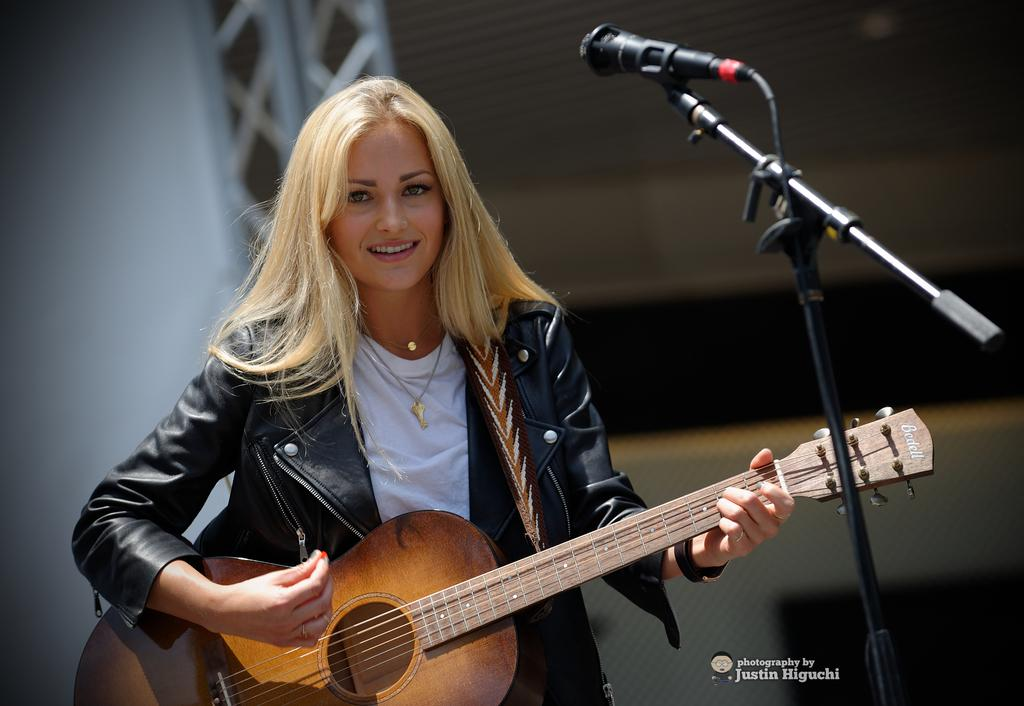Who is the main subject in the image? There is a woman in the image. What is the woman doing in the image? The woman is standing and smiling, and she is playing the guitar. What objects are related to the woman's musical performance in the image? There is a microphone and a microphone stand in the image. What type of brake can be seen on the guitar in the image? There is no brake present on the guitar in the image. What scientific experiment is being conducted in the image? There is no scientific experiment depicted in the image; it features a woman playing the guitar. 